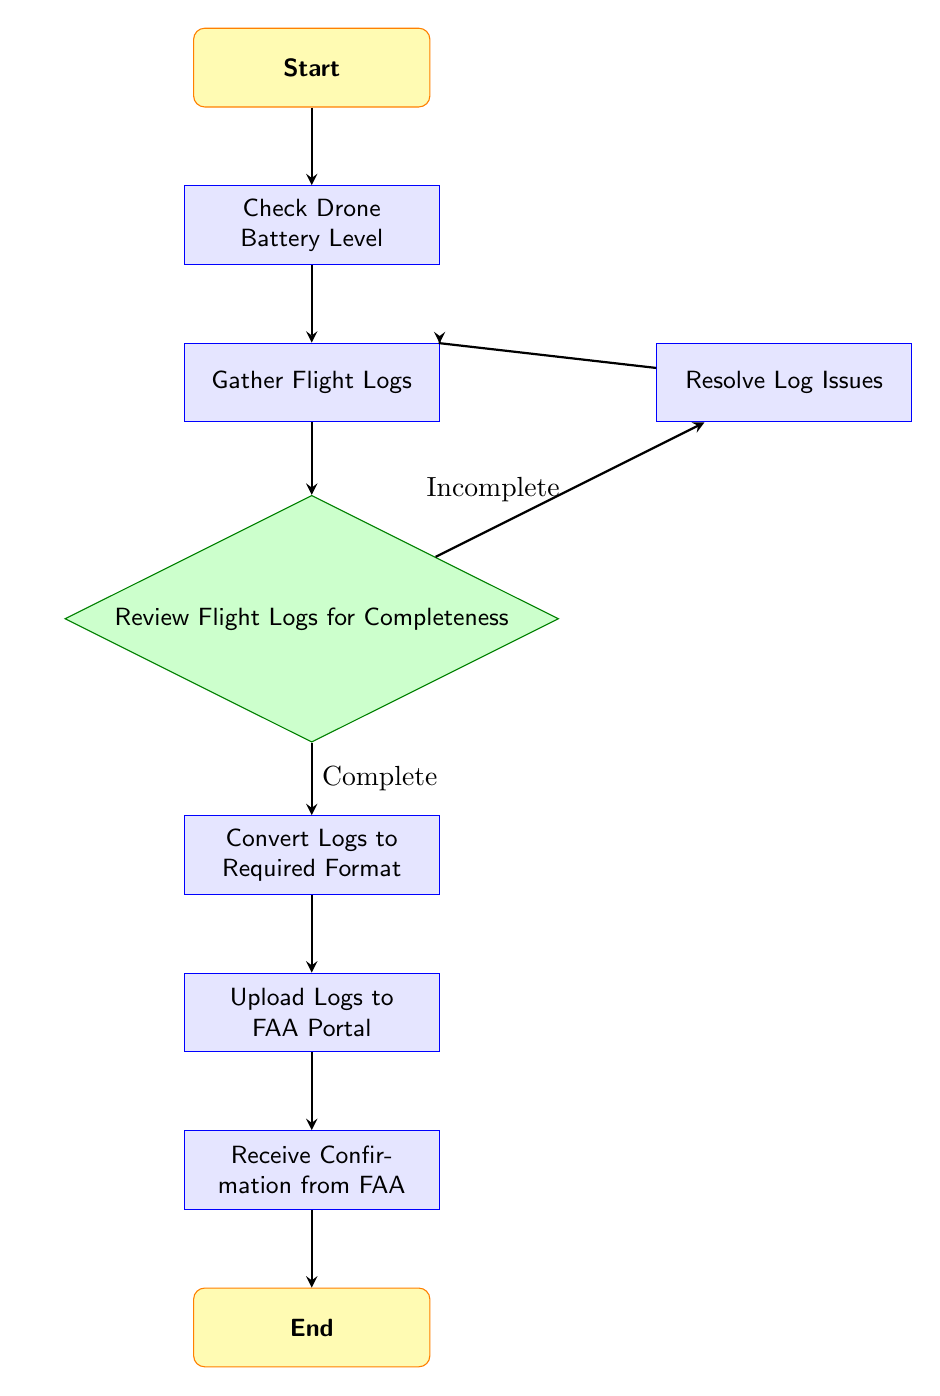What is the first step in the workflow? The first step, as indicated by the flow chart, is labeled "Start," leading to "Check Drone Battery Level."
Answer: Start How many decision points are in the diagram? There is only one decision point in the diagram, which is labeled "Review Flight Logs for Completeness."
Answer: One What action is taken if the flight logs are incomplete? If the flight logs are incomplete, the workflow indicates to "Resolve Log Issues." This step occurs before re-gathering the logs.
Answer: Resolve Log Issues What comes after converting the logs to the required format? After converting the logs to the required format, the next action is to "Upload Logs to FAA Portal."
Answer: Upload Logs to FAA Portal What is the last action in the workflow? The last action in the workflow, as per the diagram, is "Receive Confirmation from FAA," followed by the "End."
Answer: Receive Confirmation from FAA If the flight logs are complete, which node follows? If the flight logs are complete, the next node in the workflow is "Convert Logs to Required Format."
Answer: Convert Logs to Required Format What do you do after checking the drone battery level? After checking the drone battery level, the next step is to "Gather Flight Logs."
Answer: Gather Flight Logs What happens if the logs are confirmed to be complete? If the logs are confirmed to be complete, the process proceeds to "Convert Logs to Required Format."
Answer: Convert Logs to Required Format 